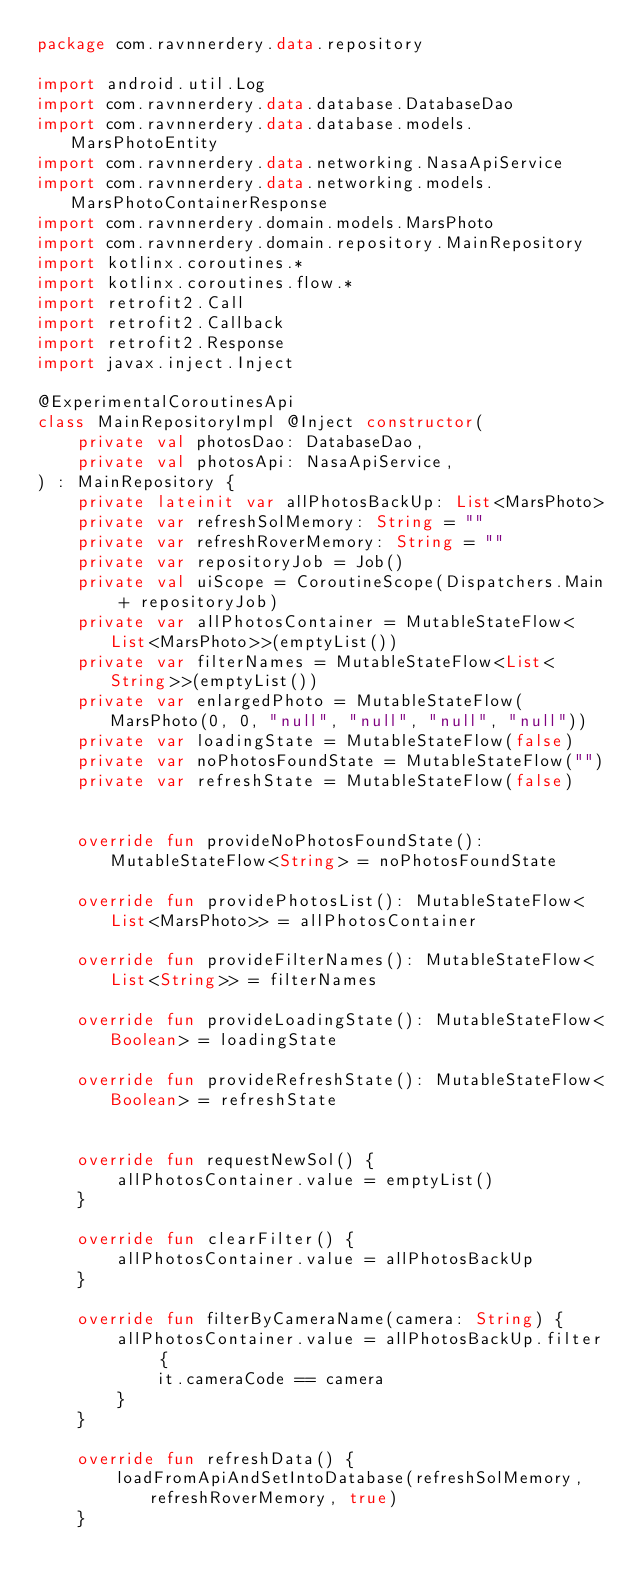<code> <loc_0><loc_0><loc_500><loc_500><_Kotlin_>package com.ravnnerdery.data.repository

import android.util.Log
import com.ravnnerdery.data.database.DatabaseDao
import com.ravnnerdery.data.database.models.MarsPhotoEntity
import com.ravnnerdery.data.networking.NasaApiService
import com.ravnnerdery.data.networking.models.MarsPhotoContainerResponse
import com.ravnnerdery.domain.models.MarsPhoto
import com.ravnnerdery.domain.repository.MainRepository
import kotlinx.coroutines.*
import kotlinx.coroutines.flow.*
import retrofit2.Call
import retrofit2.Callback
import retrofit2.Response
import javax.inject.Inject

@ExperimentalCoroutinesApi
class MainRepositoryImpl @Inject constructor(
    private val photosDao: DatabaseDao,
    private val photosApi: NasaApiService,
) : MainRepository {
    private lateinit var allPhotosBackUp: List<MarsPhoto>
    private var refreshSolMemory: String = ""
    private var refreshRoverMemory: String = ""
    private var repositoryJob = Job()
    private val uiScope = CoroutineScope(Dispatchers.Main + repositoryJob)
    private var allPhotosContainer = MutableStateFlow<List<MarsPhoto>>(emptyList())
    private var filterNames = MutableStateFlow<List<String>>(emptyList())
    private var enlargedPhoto = MutableStateFlow(MarsPhoto(0, 0, "null", "null", "null", "null"))
    private var loadingState = MutableStateFlow(false)
    private var noPhotosFoundState = MutableStateFlow("")
    private var refreshState = MutableStateFlow(false)


    override fun provideNoPhotosFoundState(): MutableStateFlow<String> = noPhotosFoundState

    override fun providePhotosList(): MutableStateFlow<List<MarsPhoto>> = allPhotosContainer

    override fun provideFilterNames(): MutableStateFlow<List<String>> = filterNames

    override fun provideLoadingState(): MutableStateFlow<Boolean> = loadingState

    override fun provideRefreshState(): MutableStateFlow<Boolean> = refreshState


    override fun requestNewSol() {
        allPhotosContainer.value = emptyList()
    }

    override fun clearFilter() {
        allPhotosContainer.value = allPhotosBackUp
    }

    override fun filterByCameraName(camera: String) {
        allPhotosContainer.value = allPhotosBackUp.filter {
            it.cameraCode == camera
        }
    }

    override fun refreshData() {
        loadFromApiAndSetIntoDatabase(refreshSolMemory, refreshRoverMemory, true)
    }
</code> 